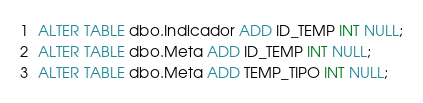Convert code to text. <code><loc_0><loc_0><loc_500><loc_500><_SQL_>
ALTER TABLE dbo.Indicador ADD ID_TEMP INT NULL;
ALTER TABLE dbo.Meta ADD ID_TEMP INT NULL;
ALTER TABLE dbo.Meta ADD TEMP_TIPO INT NULL;
</code> 